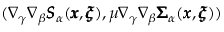<formula> <loc_0><loc_0><loc_500><loc_500>( \nabla _ { \gamma } \nabla _ { \beta } { \pm b S } _ { \alpha } ( { \pm b x } , { \pm b \xi } ) , \mu \nabla _ { \gamma } \nabla _ { \beta } { \pm b \Sigma } _ { \alpha } ( { \pm b x } , { \pm b \xi } ) )</formula> 